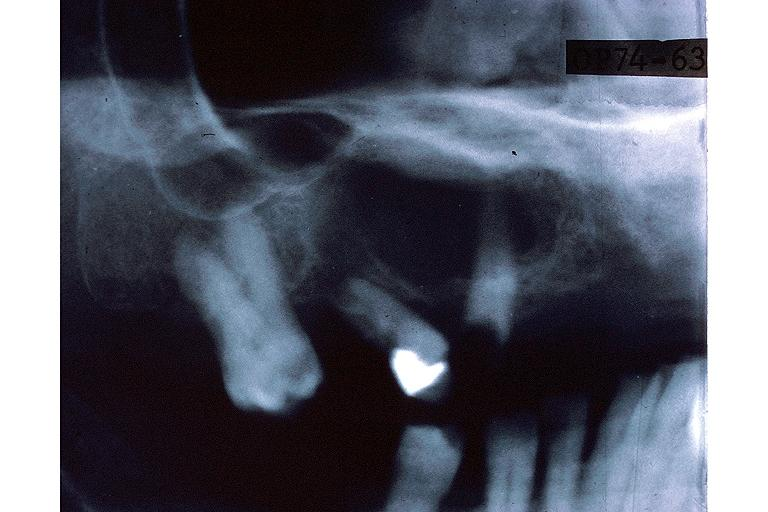s excellent example case present?
Answer the question using a single word or phrase. No 